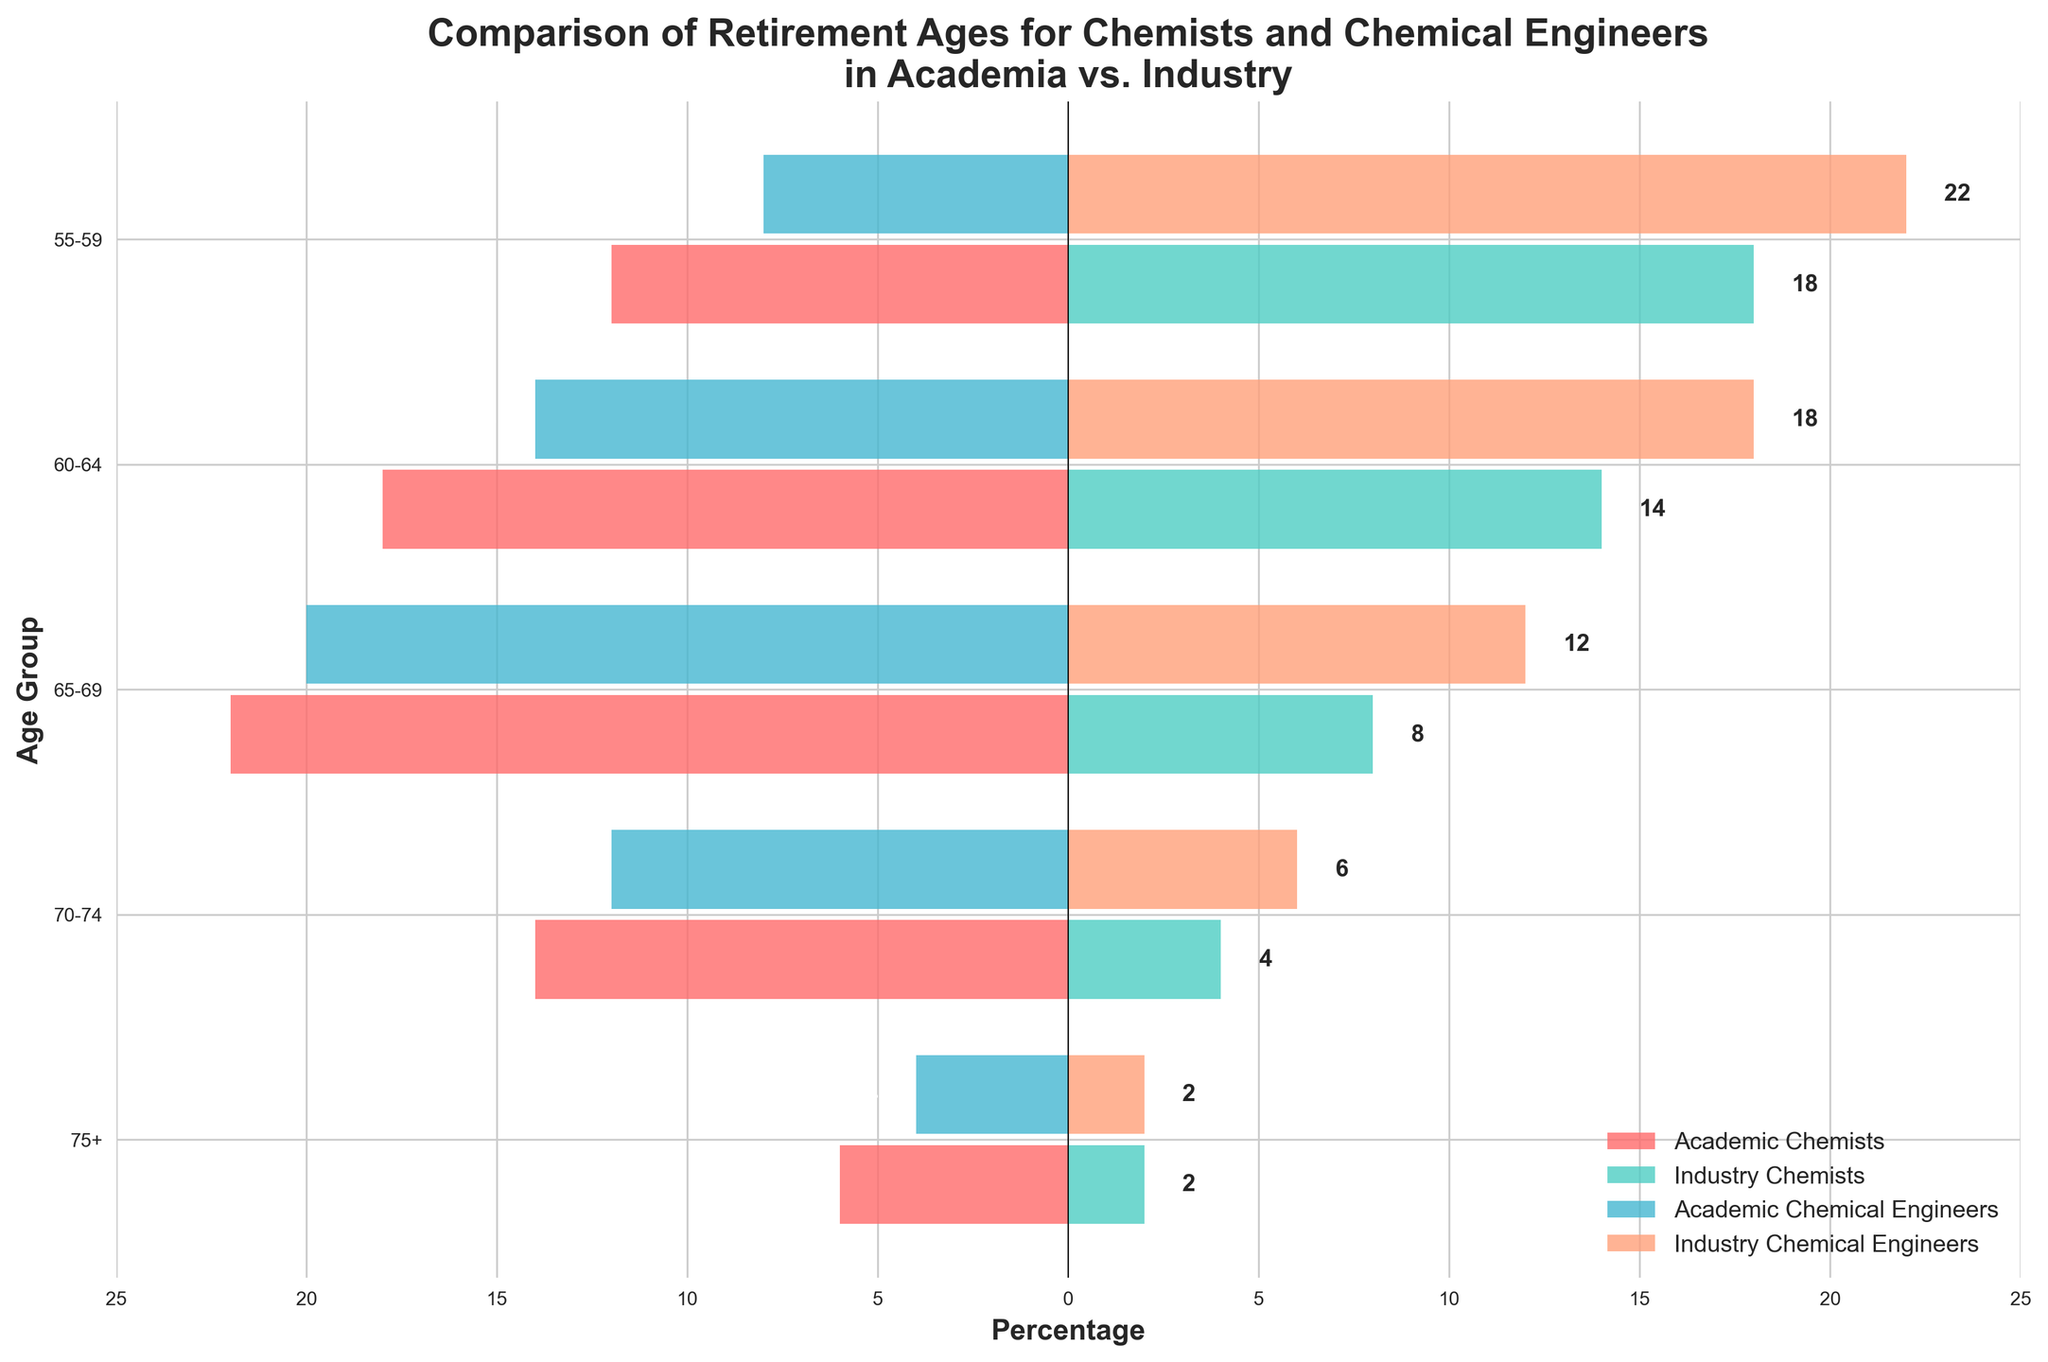What's the title of the figure? The title is usually at the top of the figure and provides a brief description of what the figure represents. In this case, it reads "Comparison of Retirement Ages for Chemists and Chemical Engineers in Academia vs. Industry".
Answer: Comparison of Retirement Ages for Chemists and Chemical Engineers in Academia vs. Industry What does the x-axis represent? The x-axis label indicates the meaning of the horizontal bar lengths. Here, it is labeled as "Percentage", meaning the length of each bar represents the percentage of people within that age group.
Answer: Percentage Which age group has the highest number of Industry Chemists? By examining the green bars representing Industry Chemists, the bar for the 55-59 age group is the longest, indicating it has the highest number of Industry Chemists.
Answer: 55-59 For the age group 65-69, which group of professionals has the lowest numbers in academia? Looking at the bars for age group 65-69, the blue bar represents Academic Chemical Engineers and it extends further left than the red bar for Academic Chemists, indicating lower numbers.
Answer: Academic Chemical Engineers In which age group is the difference between Industry Chemical Engineers and Academic Chemical Engineers the largest? To find the largest difference, compare the length of the purple bar (Industry Chemical Engineers) to the light blue bar (Academic Chemical Engineers) for each age group. The 65-69 group shows the largest total difference, with 32 percentage points (12 for Industry and -20 for Academic).
Answer: 65-69 Which age group has the closest numbers for Academic Chemists and Academic Chemical Engineers? Look at the bars for Academic Chemists (red) and Academic Chemical Engineers (blue) for each age group. For the 75+ group, the red bar is at -6 and the blue bar is at -4, making their numbers the closest.
Answer: 75+ Are there more Industry Chemists or Industry Chemical Engineers in the 60-64 age group? Compare the lengths of the green bar (Industry Chemists) and the purple bar (Industry Chemical Engineers) for the 60-64 age group. The green bar at 14 is shorter than the purple bar at 18.
Answer: Industry Chemical Engineers How many groups of colors are used to represent different professions? There are four distinctive colors used: red for Academic Chemists, green for Industry Chemists, blue for Academic Chemical Engineers, and purple for Industry Chemical Engineers.
Answer: Four What is the overall trend in the number of academic retirees in both Chemists and Chemical Engineers as age increases? Observing the red and blue bars for Academic Chemists and Academic Chemical Engineers respectively, there is a general trend of decreasing numbers as age increases from 55-59 to 75+.
Answer: Decreasing What’s the largest number shown for Academic Chemists and in which age group? Looking at the maximum length of the red bars for Academic Chemists, the largest negative value is -22 in the age group 65-69.
Answer: -22 in 65-69 